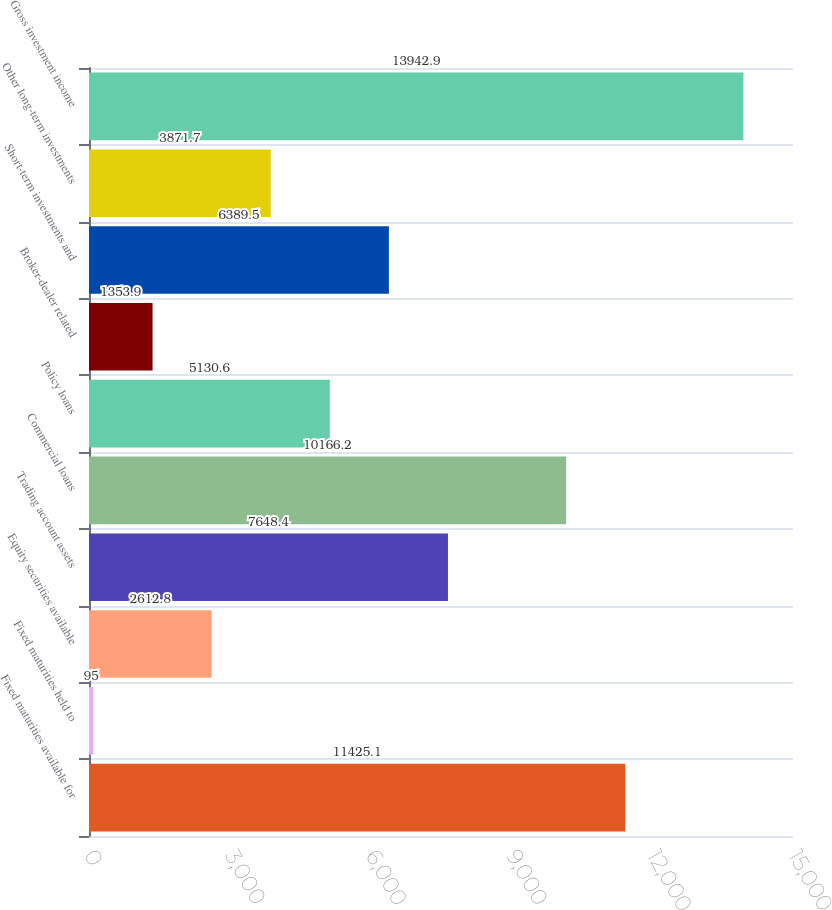<chart> <loc_0><loc_0><loc_500><loc_500><bar_chart><fcel>Fixed maturities available for<fcel>Fixed maturities held to<fcel>Equity securities available<fcel>Trading account assets<fcel>Commercial loans<fcel>Policy loans<fcel>Broker-dealer related<fcel>Short-term investments and<fcel>Other long-term investments<fcel>Gross investment income<nl><fcel>11425.1<fcel>95<fcel>2612.8<fcel>7648.4<fcel>10166.2<fcel>5130.6<fcel>1353.9<fcel>6389.5<fcel>3871.7<fcel>13942.9<nl></chart> 